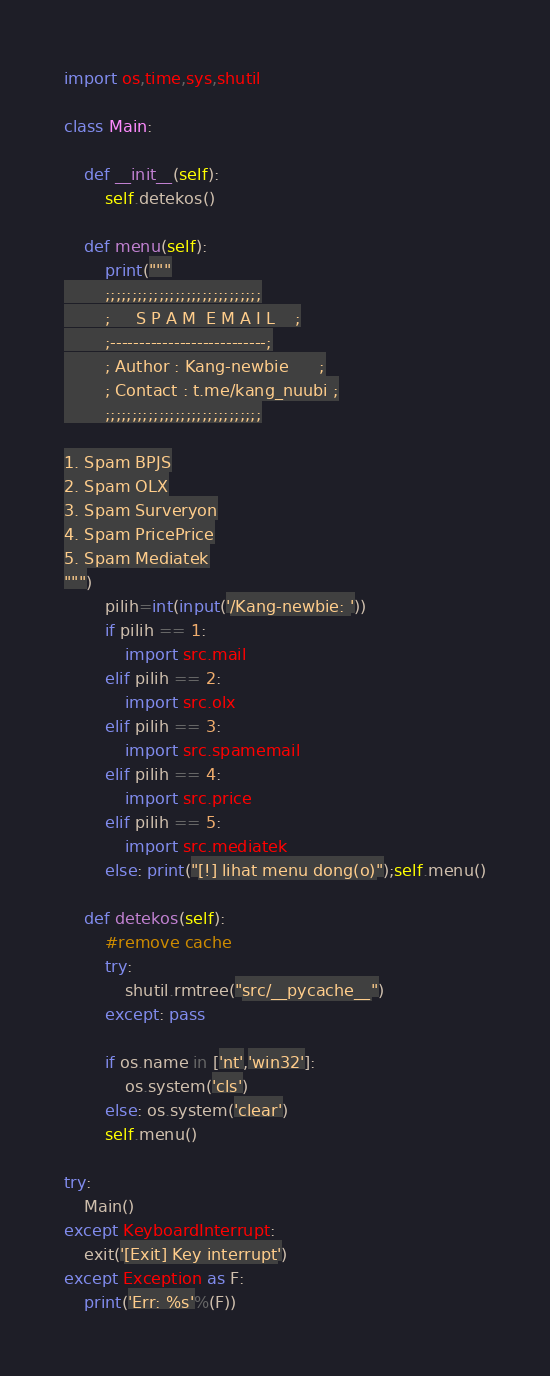Convert code to text. <code><loc_0><loc_0><loc_500><loc_500><_Python_>import os,time,sys,shutil

class Main:

	def __init__(self):
		self.detekos()

	def menu(self):
		print("""
		;;;;;;;;;;;;;;;;;;;;;;;;;;;;;
		;     S P A M  E M A I L    ;
		;---------------------------;
		; Author : Kang-newbie      ;
		; Contact : t.me/kang_nuubi ;
		;;;;;;;;;;;;;;;;;;;;;;;;;;;;;

1. Spam BPJS
2. Spam OLX
3. Spam Surveryon
4. Spam PricePrice
5. Spam Mediatek
""")
		pilih=int(input('/Kang-newbie: '))
		if pilih == 1:
			import src.mail
		elif pilih == 2:
			import src.olx
		elif pilih == 3:
			import src.spamemail
		elif pilih == 4:
			import src.price
		elif pilih == 5:
			import src.mediatek
		else: print("[!] lihat menu dong(o)");self.menu()

	def detekos(self):
		#remove cache
		try:
			shutil.rmtree("src/__pycache__")
		except: pass

		if os.name in ['nt','win32']:
			os.system('cls')
		else: os.system('clear')
		self.menu()

try:
	Main()
except KeyboardInterrupt:
	exit('[Exit] Key interrupt')
except Exception as F:
	print('Err: %s'%(F))
</code> 